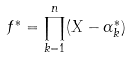Convert formula to latex. <formula><loc_0><loc_0><loc_500><loc_500>f ^ { * } = \prod _ { k = 1 } ^ { n } ( X - \alpha _ { k } ^ { * } )</formula> 